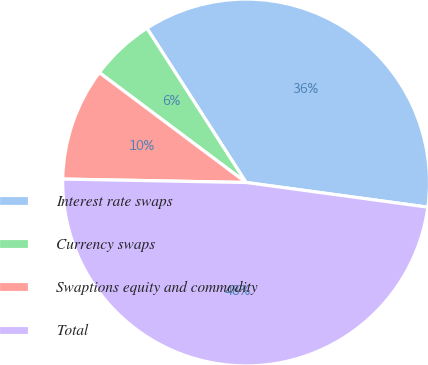<chart> <loc_0><loc_0><loc_500><loc_500><pie_chart><fcel>Interest rate swaps<fcel>Currency swaps<fcel>Swaptions equity and commodity<fcel>Total<nl><fcel>36.24%<fcel>5.68%<fcel>9.93%<fcel>48.15%<nl></chart> 